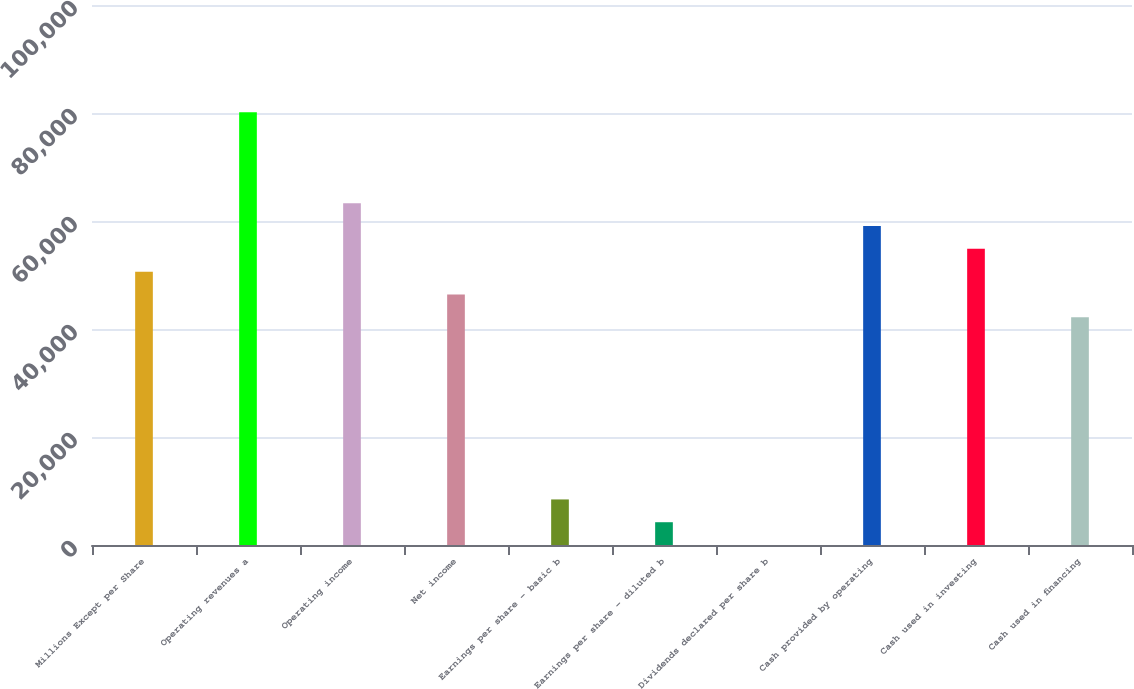Convert chart to OTSL. <chart><loc_0><loc_0><loc_500><loc_500><bar_chart><fcel>Millions Except per Share<fcel>Operating revenues a<fcel>Operating income<fcel>Net income<fcel>Earnings per share - basic b<fcel>Earnings per share - diluted b<fcel>Dividends declared per share b<fcel>Cash provided by operating<fcel>Cash used in investing<fcel>Cash used in financing<nl><fcel>50620.6<fcel>80148.6<fcel>63275.4<fcel>46402.3<fcel>8437.66<fcel>4219.37<fcel>1.08<fcel>59057.1<fcel>54838.8<fcel>42184<nl></chart> 